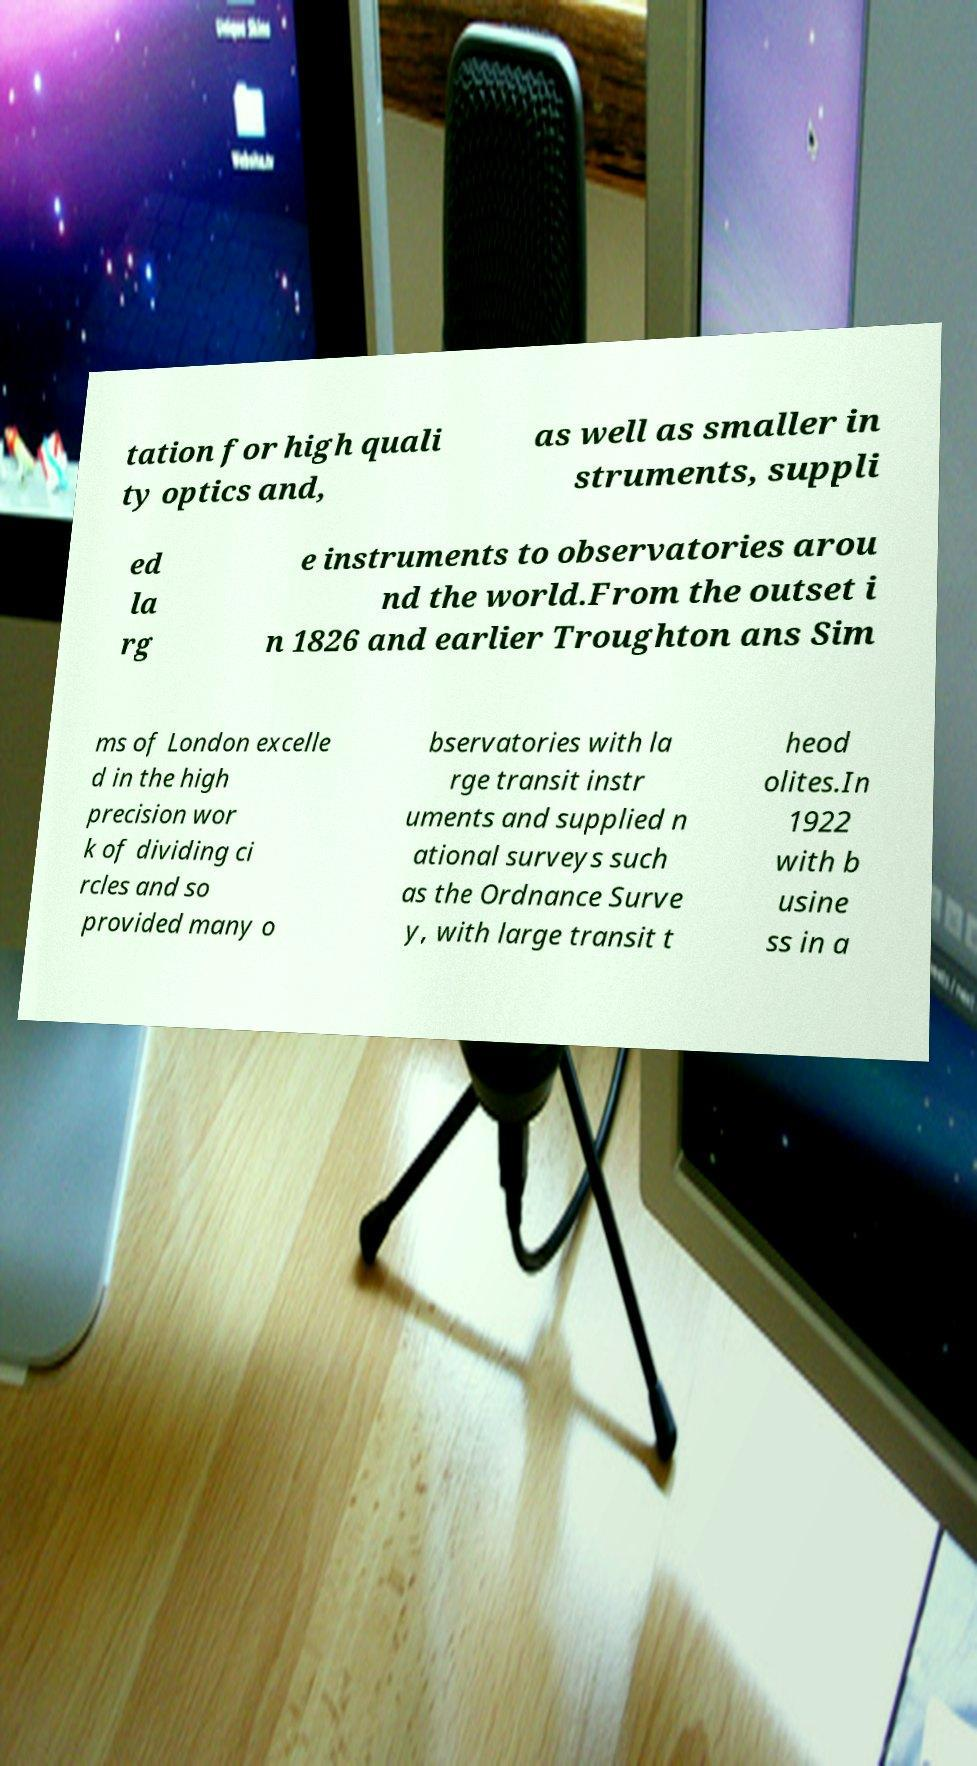I need the written content from this picture converted into text. Can you do that? tation for high quali ty optics and, as well as smaller in struments, suppli ed la rg e instruments to observatories arou nd the world.From the outset i n 1826 and earlier Troughton ans Sim ms of London excelle d in the high precision wor k of dividing ci rcles and so provided many o bservatories with la rge transit instr uments and supplied n ational surveys such as the Ordnance Surve y, with large transit t heod olites.In 1922 with b usine ss in a 